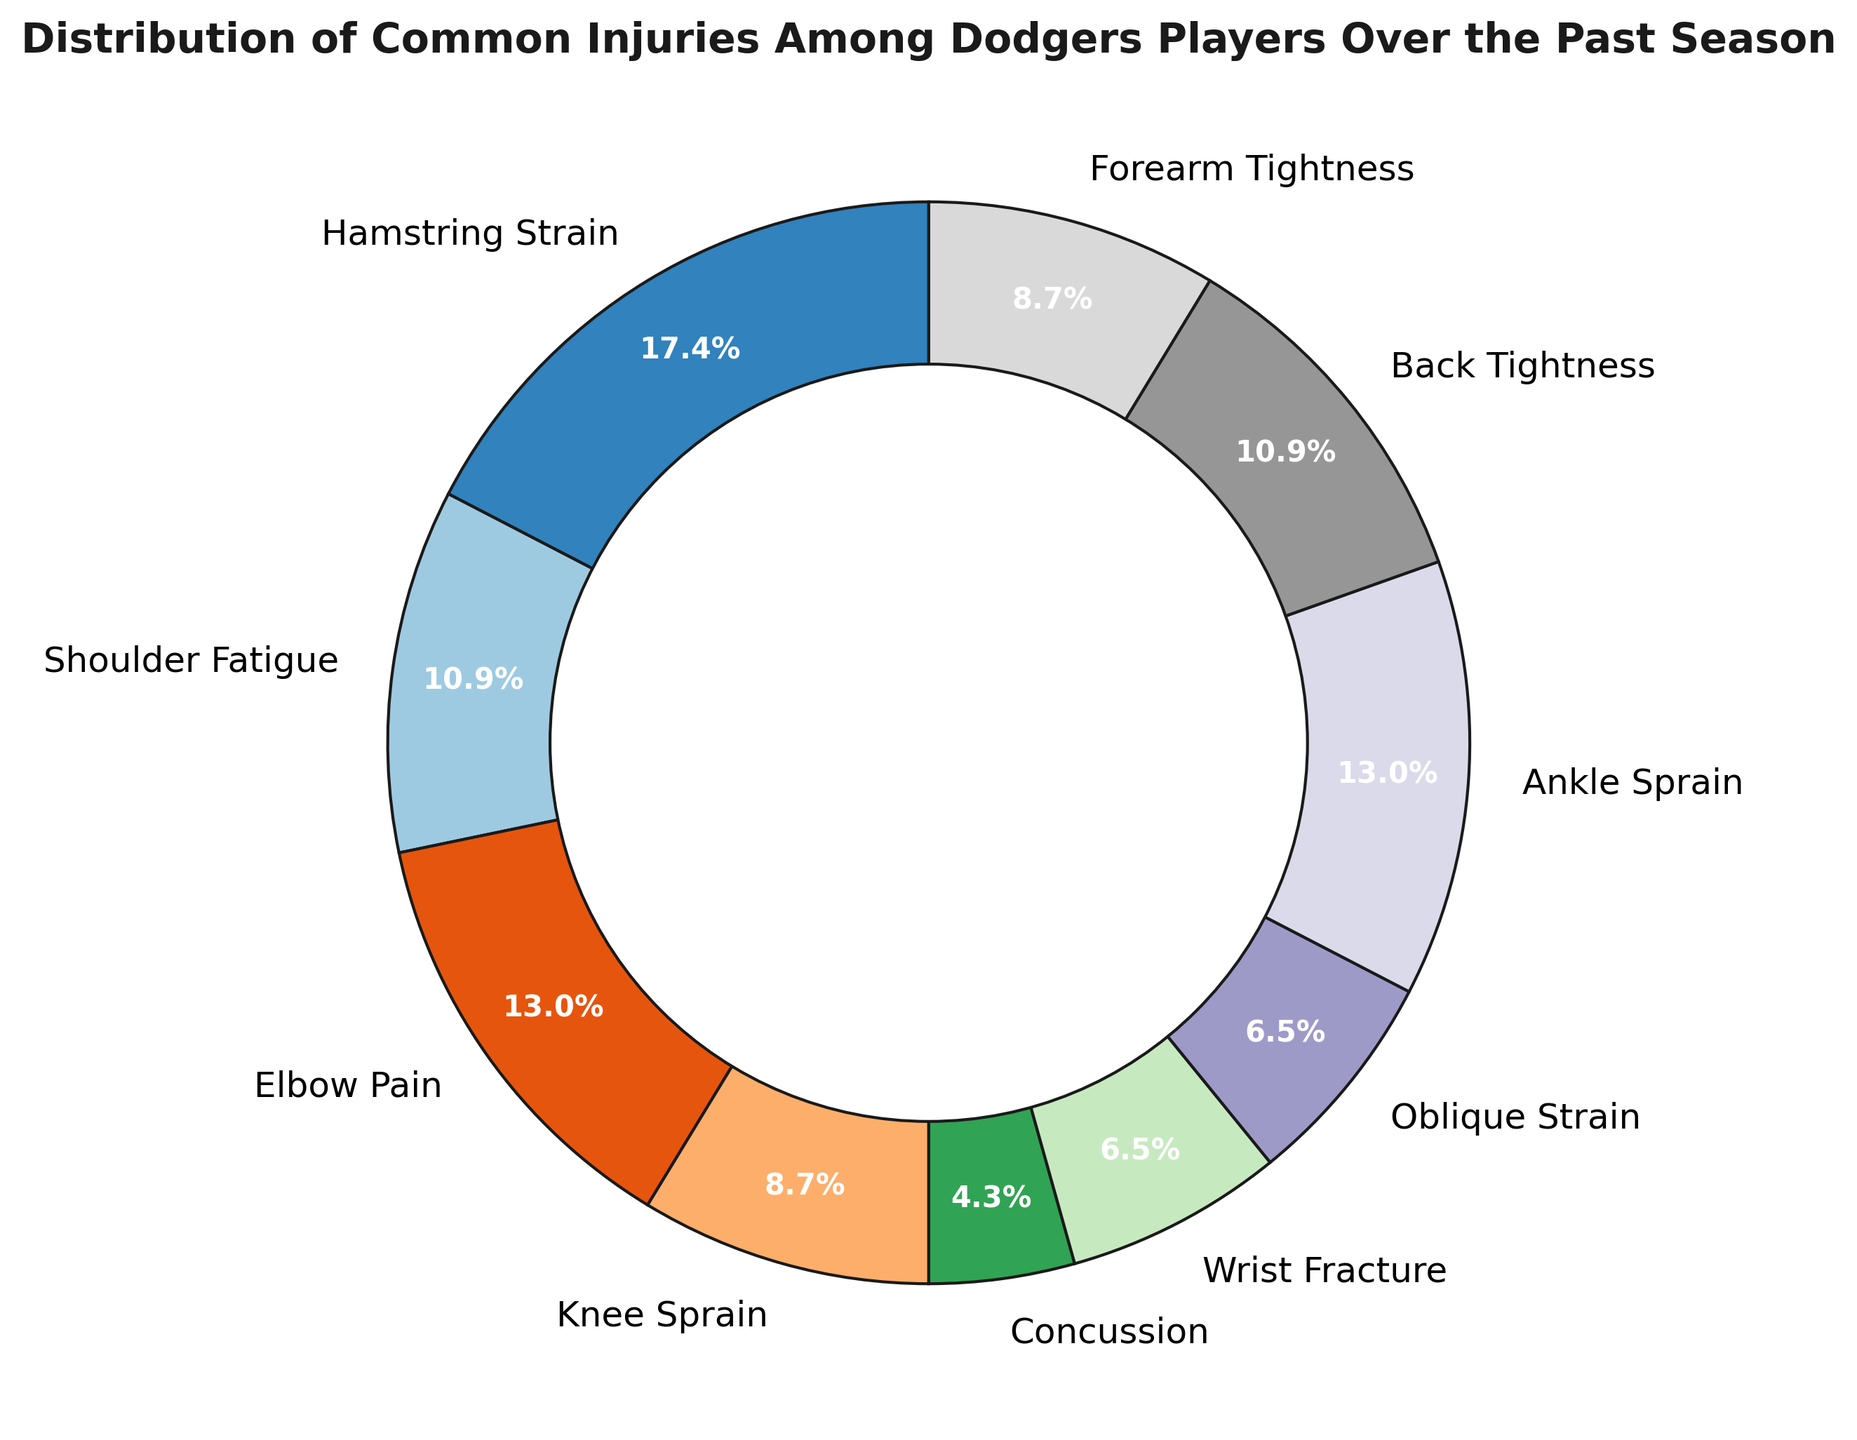Which injury type occurred the most among Dodgers players over the past season? By looking at the pie chart, we can see which segment is the largest in terms of the proportion of injuries. The injury with the largest segment represents the injury type that occurred the most.
Answer: Hamstring Strain Which two injury types have the same number of occurrences? Check the labels in the pie chart and identify segments that show the same percentages. The injury types with matching percentages indicate the same number of occurrences.
Answer: Wrist Fracture and Oblique Strain What percentage of injuries were Elbow Pain? Find the segment labeled Elbow Pain and read the percentage shown on the pie chart for that segment.
Answer: 11.5% How many more cases of Hamstring Strain were there compared to Concussion? Determine the counts from the data: Hamstring Strain (8) and Concussion (2). Subtract the number of Concussion cases from Hamstring Strain cases to find the difference.
Answer: 6 What is the total count of injuries related to leg (Hamstring Strain, Knee Sprain, and Ankle Sprain)? Sum the counts of Hamstring Strain (8), Knee Sprain (4), and Ankle Sprain (6) to get the total count.
Answer: 18 How do Shoulder Fatigue and Back Tightness compare in terms of injuries? Compare the numbers from the pie chart or data. Count for Shoulder Fatigue is 5, and for Back Tightness, it is also 5.
Answer: They are equal What is the combined percentage of Forearm Tightness and Wrist Fracture injuries? Find the percentages for Forearm Tightness and Wrist Fracture on the pie chart, which are 7.7% each. Then, add these two percentages together.
Answer: 15.4% Which injury types account for less than 10% of the total injuries? Identify the segments in the pie chart where the percentage is less than 10%. List those injury types.
Answer: Concussion and Wrist Fracture 